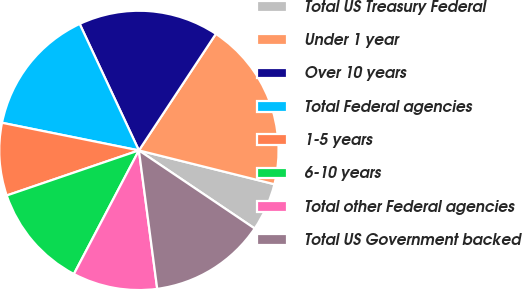<chart> <loc_0><loc_0><loc_500><loc_500><pie_chart><fcel>Total US Treasury Federal<fcel>Under 1 year<fcel>Over 10 years<fcel>Total Federal agencies<fcel>1-5 years<fcel>6-10 years<fcel>Total other Federal agencies<fcel>Total US Government backed<nl><fcel>5.55%<fcel>19.6%<fcel>16.26%<fcel>14.86%<fcel>8.4%<fcel>12.06%<fcel>9.8%<fcel>13.46%<nl></chart> 